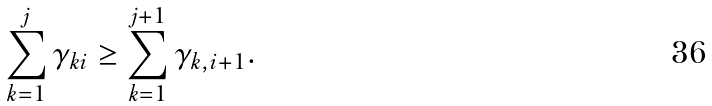<formula> <loc_0><loc_0><loc_500><loc_500>\sum _ { k = 1 } ^ { j } \gamma _ { k i } \geq \sum _ { k = 1 } ^ { j + 1 } \gamma _ { k , i + 1 } .</formula> 